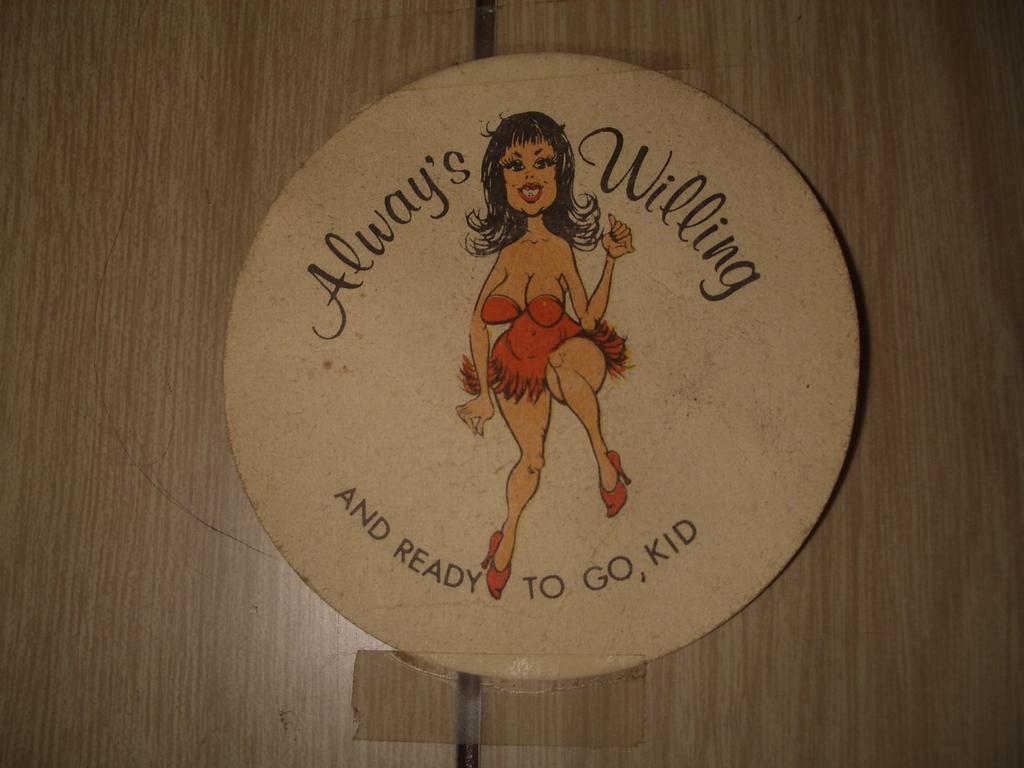Could you give a brief overview of what you see in this image? In this image in the center there is a board, on the board there is text and depiction of a woman and in the background there are wooden board. 